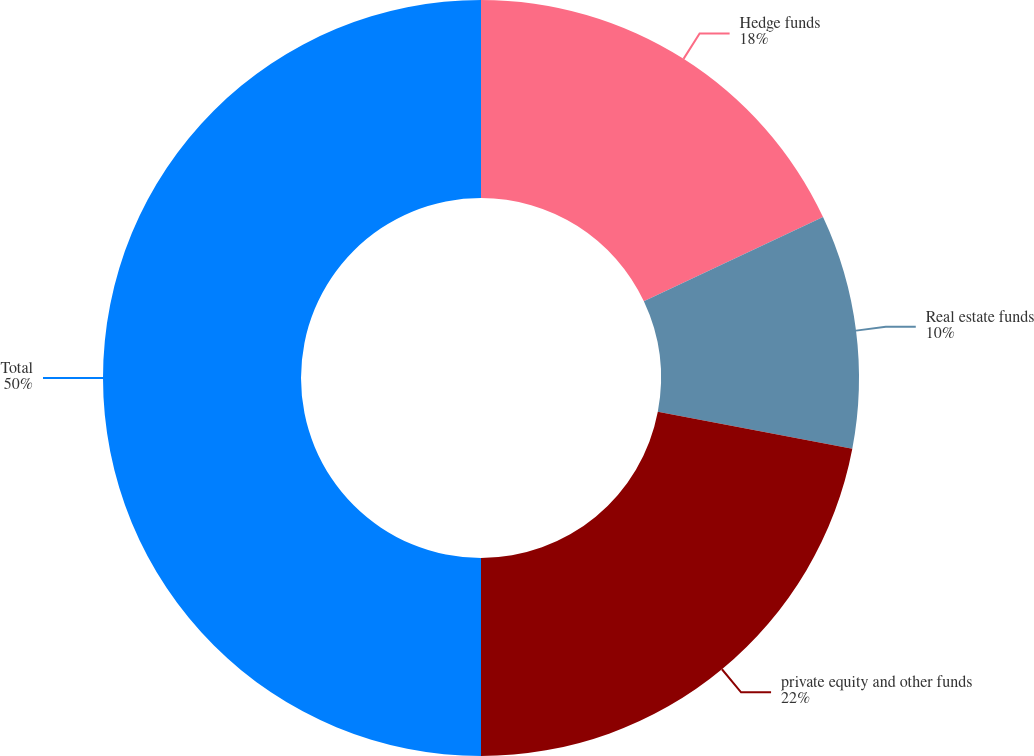<chart> <loc_0><loc_0><loc_500><loc_500><pie_chart><fcel>Hedge funds<fcel>Real estate funds<fcel>private equity and other funds<fcel>Total<nl><fcel>18.0%<fcel>10.0%<fcel>22.0%<fcel>50.0%<nl></chart> 